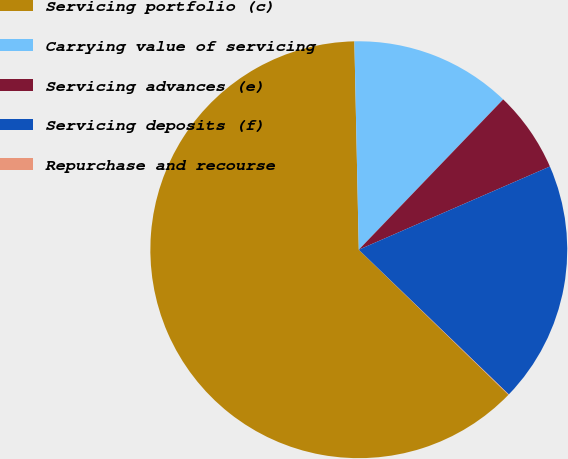Convert chart to OTSL. <chart><loc_0><loc_0><loc_500><loc_500><pie_chart><fcel>Servicing portfolio (c)<fcel>Carrying value of servicing<fcel>Servicing advances (e)<fcel>Servicing deposits (f)<fcel>Repurchase and recourse<nl><fcel>62.41%<fcel>12.52%<fcel>6.28%<fcel>18.75%<fcel>0.04%<nl></chart> 